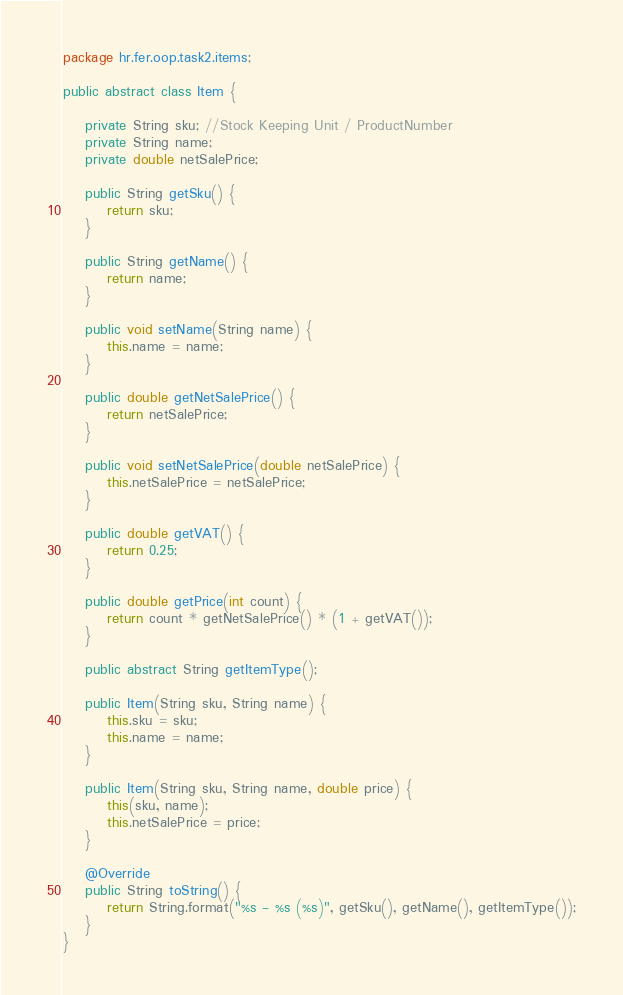<code> <loc_0><loc_0><loc_500><loc_500><_Java_>package hr.fer.oop.task2.items;

public abstract class Item {

    private String sku; //Stock Keeping Unit / ProductNumber
    private String name;
    private double netSalePrice;

    public String getSku() {
        return sku;
    }

    public String getName() {
        return name;
    }

    public void setName(String name) {
        this.name = name;
    }

    public double getNetSalePrice() {
        return netSalePrice;
    }

    public void setNetSalePrice(double netSalePrice) {
        this.netSalePrice = netSalePrice;
    }

    public double getVAT() {
        return 0.25;
    }

    public double getPrice(int count) {
        return count * getNetSalePrice() * (1 + getVAT());
    }

    public abstract String getItemType();

    public Item(String sku, String name) {
        this.sku = sku;
        this.name = name;
    }

    public Item(String sku, String name, double price) {
        this(sku, name);
        this.netSalePrice = price;
    }

    @Override
    public String toString() {
        return String.format("%s - %s (%s)", getSku(), getName(), getItemType());
    }
}
</code> 